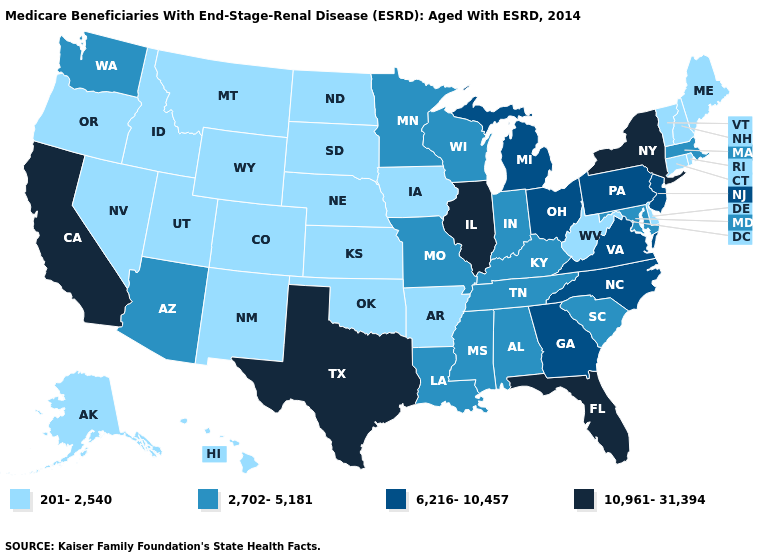What is the value of Maryland?
Be succinct. 2,702-5,181. Does the first symbol in the legend represent the smallest category?
Answer briefly. Yes. Name the states that have a value in the range 6,216-10,457?
Write a very short answer. Georgia, Michigan, New Jersey, North Carolina, Ohio, Pennsylvania, Virginia. Among the states that border Utah , does New Mexico have the highest value?
Concise answer only. No. Name the states that have a value in the range 201-2,540?
Keep it brief. Alaska, Arkansas, Colorado, Connecticut, Delaware, Hawaii, Idaho, Iowa, Kansas, Maine, Montana, Nebraska, Nevada, New Hampshire, New Mexico, North Dakota, Oklahoma, Oregon, Rhode Island, South Dakota, Utah, Vermont, West Virginia, Wyoming. Does South Dakota have a lower value than Oklahoma?
Be succinct. No. What is the value of Connecticut?
Short answer required. 201-2,540. Does the first symbol in the legend represent the smallest category?
Quick response, please. Yes. Which states have the highest value in the USA?
Keep it brief. California, Florida, Illinois, New York, Texas. What is the highest value in the USA?
Concise answer only. 10,961-31,394. What is the lowest value in the MidWest?
Keep it brief. 201-2,540. Name the states that have a value in the range 2,702-5,181?
Keep it brief. Alabama, Arizona, Indiana, Kentucky, Louisiana, Maryland, Massachusetts, Minnesota, Mississippi, Missouri, South Carolina, Tennessee, Washington, Wisconsin. What is the value of Pennsylvania?
Concise answer only. 6,216-10,457. What is the value of New Jersey?
Quick response, please. 6,216-10,457. 